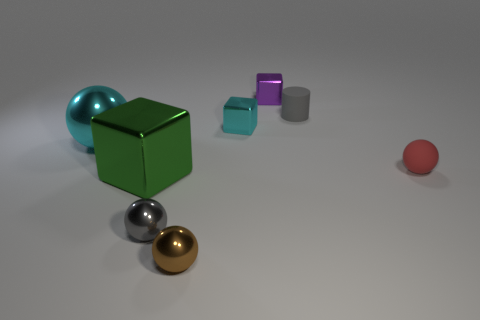There is a small metal thing that is the same color as the matte cylinder; what shape is it?
Ensure brevity in your answer.  Sphere. How many small matte things are on the right side of the small matte object left of the tiny rubber thing that is on the right side of the cylinder?
Provide a succinct answer. 1. There is a sphere that is right of the small block behind the tiny cylinder; what is its size?
Give a very brief answer. Small. What is the size of the cyan block that is made of the same material as the purple object?
Your answer should be very brief. Small. There is a object that is behind the brown metallic ball and in front of the big green thing; what shape is it?
Your response must be concise. Sphere. Are there an equal number of balls behind the gray ball and small brown objects?
Your response must be concise. No. How many things are large blue objects or gray things behind the cyan shiny ball?
Your answer should be compact. 1. Is there a small gray object that has the same shape as the small red thing?
Give a very brief answer. Yes. Are there the same number of cylinders that are in front of the matte sphere and cyan metal spheres to the right of the cyan ball?
Offer a very short reply. Yes. Is there anything else that has the same size as the matte ball?
Offer a very short reply. Yes. 